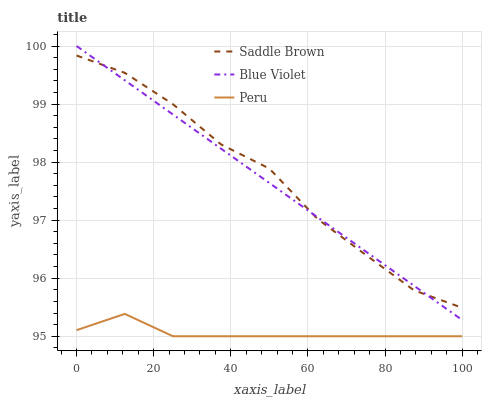Does Peru have the minimum area under the curve?
Answer yes or no. Yes. Does Saddle Brown have the maximum area under the curve?
Answer yes or no. Yes. Does Blue Violet have the minimum area under the curve?
Answer yes or no. No. Does Blue Violet have the maximum area under the curve?
Answer yes or no. No. Is Blue Violet the smoothest?
Answer yes or no. Yes. Is Saddle Brown the roughest?
Answer yes or no. Yes. Is Saddle Brown the smoothest?
Answer yes or no. No. Is Blue Violet the roughest?
Answer yes or no. No. Does Peru have the lowest value?
Answer yes or no. Yes. Does Blue Violet have the lowest value?
Answer yes or no. No. Does Blue Violet have the highest value?
Answer yes or no. Yes. Does Saddle Brown have the highest value?
Answer yes or no. No. Is Peru less than Blue Violet?
Answer yes or no. Yes. Is Saddle Brown greater than Peru?
Answer yes or no. Yes. Does Blue Violet intersect Saddle Brown?
Answer yes or no. Yes. Is Blue Violet less than Saddle Brown?
Answer yes or no. No. Is Blue Violet greater than Saddle Brown?
Answer yes or no. No. Does Peru intersect Blue Violet?
Answer yes or no. No. 